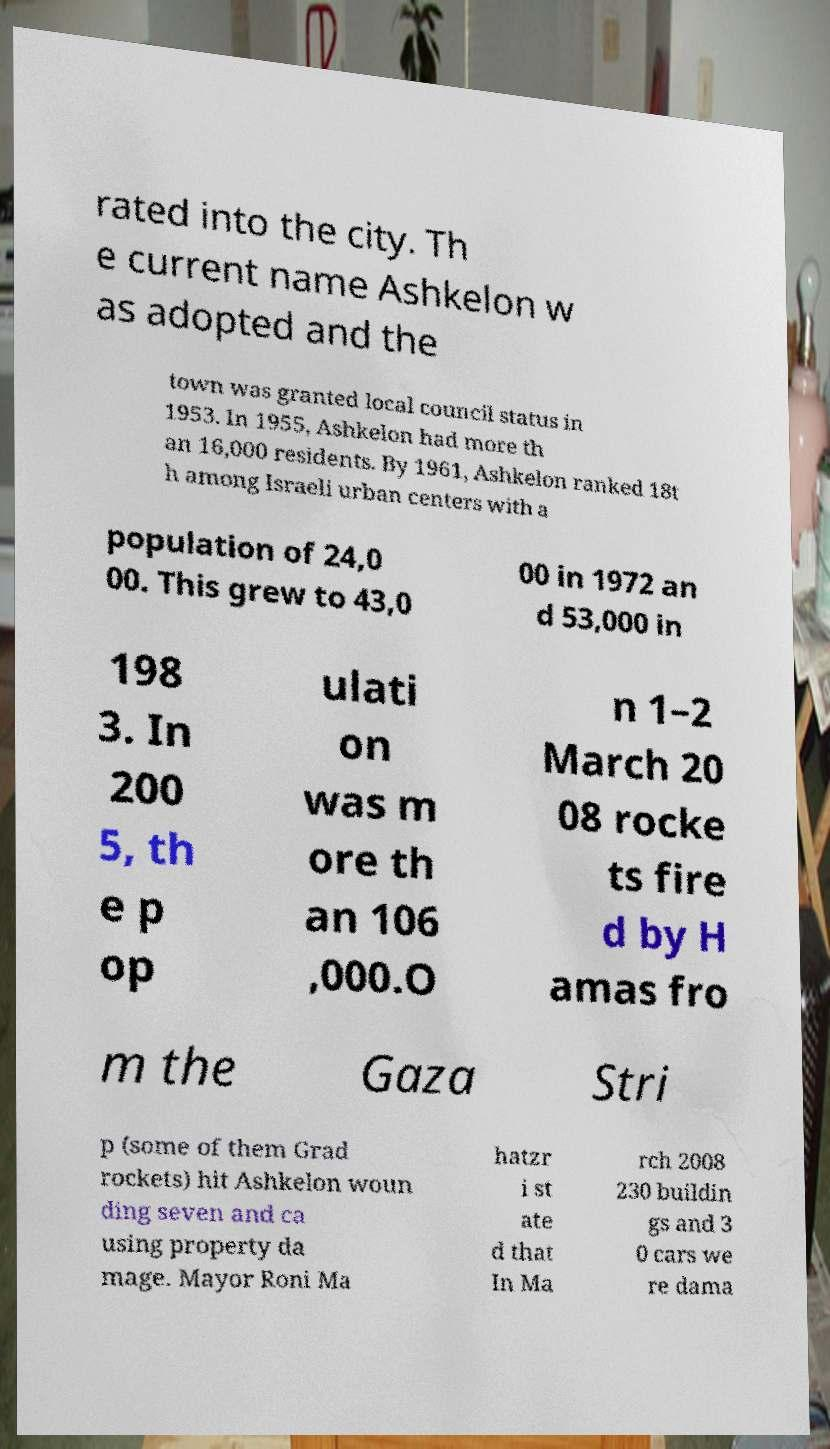Can you accurately transcribe the text from the provided image for me? rated into the city. Th e current name Ashkelon w as adopted and the town was granted local council status in 1953. In 1955, Ashkelon had more th an 16,000 residents. By 1961, Ashkelon ranked 18t h among Israeli urban centers with a population of 24,0 00. This grew to 43,0 00 in 1972 an d 53,000 in 198 3. In 200 5, th e p op ulati on was m ore th an 106 ,000.O n 1–2 March 20 08 rocke ts fire d by H amas fro m the Gaza Stri p (some of them Grad rockets) hit Ashkelon woun ding seven and ca using property da mage. Mayor Roni Ma hatzr i st ate d that In Ma rch 2008 230 buildin gs and 3 0 cars we re dama 